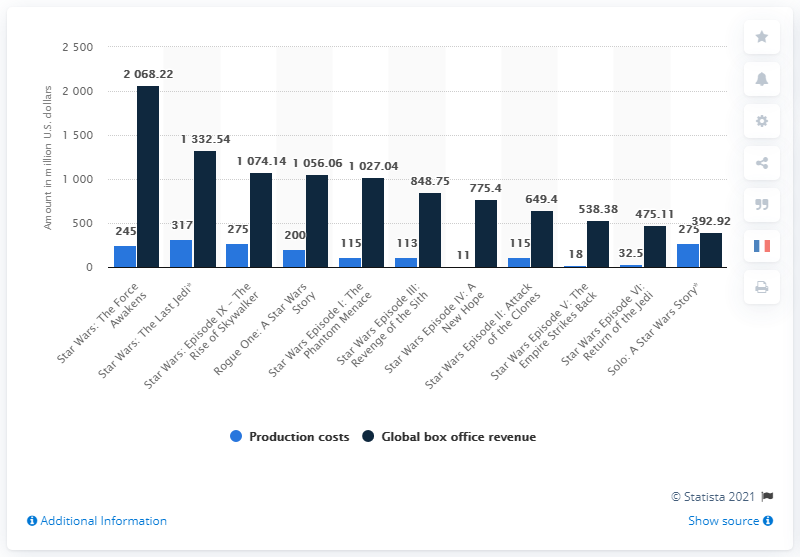Outline some significant characteristics in this image. The production cost of "A New Hope" was approximately $11 million. The worldwide box office revenue of "A New Hope" was 775.4 million dollars. 